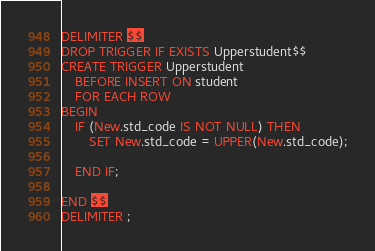<code> <loc_0><loc_0><loc_500><loc_500><_SQL_>DELIMITER $$
DROP TRIGGER IF EXISTS Upperstudent$$
CREATE TRIGGER Upperstudent
    BEFORE INSERT ON student
    FOR EACH ROW
BEGIN
    IF (New.std_code IS NOT NULL) THEN
        SET New.std_code = UPPER(New.std_code);
        
    END IF;

END $$
DELIMITER ;</code> 